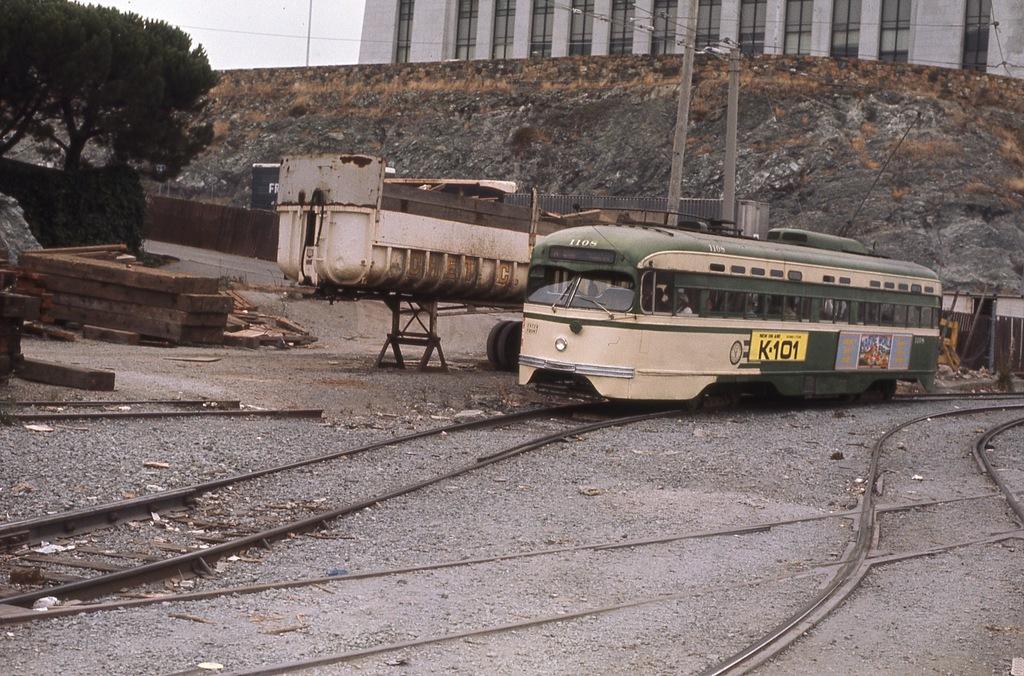What is the number on the yellow?
Ensure brevity in your answer.  101. 